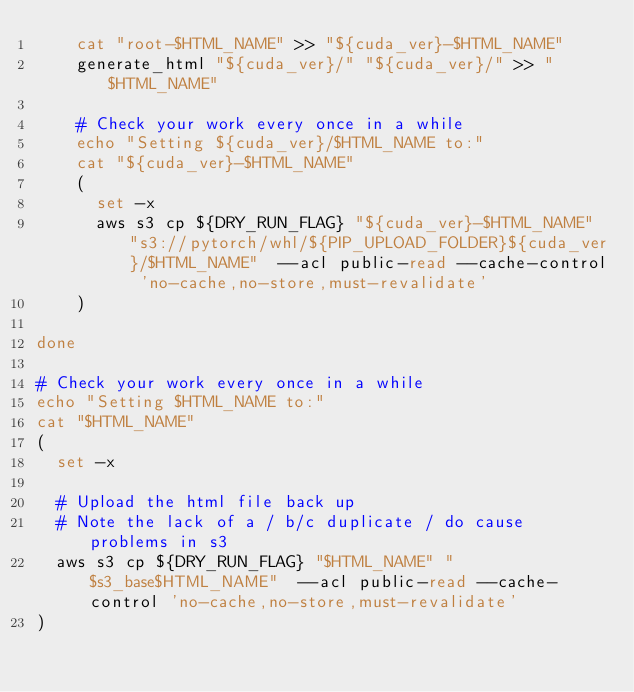Convert code to text. <code><loc_0><loc_0><loc_500><loc_500><_Bash_>    cat "root-$HTML_NAME" >> "${cuda_ver}-$HTML_NAME"
    generate_html "${cuda_ver}/" "${cuda_ver}/" >> "$HTML_NAME"

    # Check your work every once in a while
    echo "Setting ${cuda_ver}/$HTML_NAME to:"
    cat "${cuda_ver}-$HTML_NAME"
    (
      set -x
      aws s3 cp ${DRY_RUN_FLAG} "${cuda_ver}-$HTML_NAME" "s3://pytorch/whl/${PIP_UPLOAD_FOLDER}${cuda_ver}/$HTML_NAME"  --acl public-read --cache-control 'no-cache,no-store,must-revalidate'
    )

done

# Check your work every once in a while
echo "Setting $HTML_NAME to:"
cat "$HTML_NAME"
(
  set -x

  # Upload the html file back up
  # Note the lack of a / b/c duplicate / do cause problems in s3
  aws s3 cp ${DRY_RUN_FLAG} "$HTML_NAME" "$s3_base$HTML_NAME"  --acl public-read --cache-control 'no-cache,no-store,must-revalidate'
)
</code> 